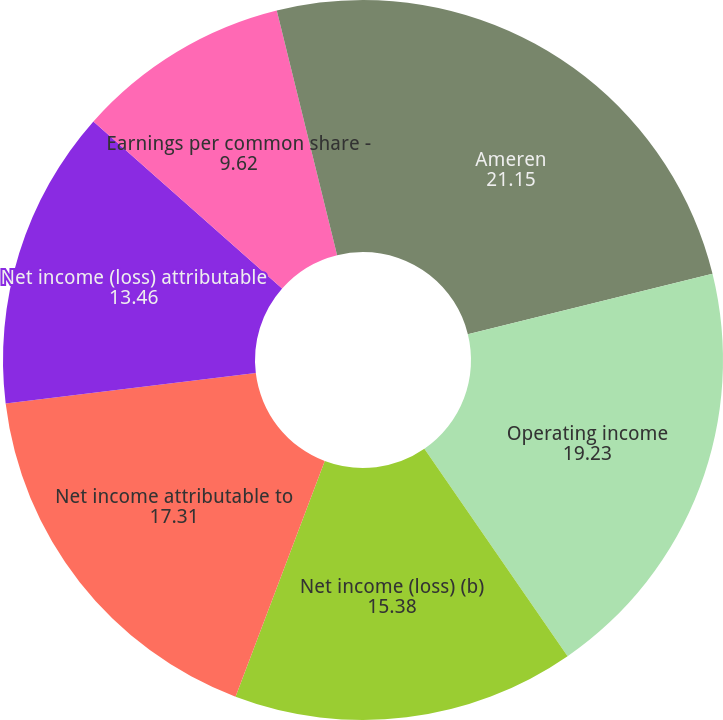<chart> <loc_0><loc_0><loc_500><loc_500><pie_chart><fcel>Ameren<fcel>Operating income<fcel>Net income (loss) (b)<fcel>Net income attributable to<fcel>Net income (loss) attributable<fcel>Earnings per common share -<fcel>Earnings (loss) per common<nl><fcel>21.15%<fcel>19.23%<fcel>15.38%<fcel>17.31%<fcel>13.46%<fcel>9.62%<fcel>3.85%<nl></chart> 